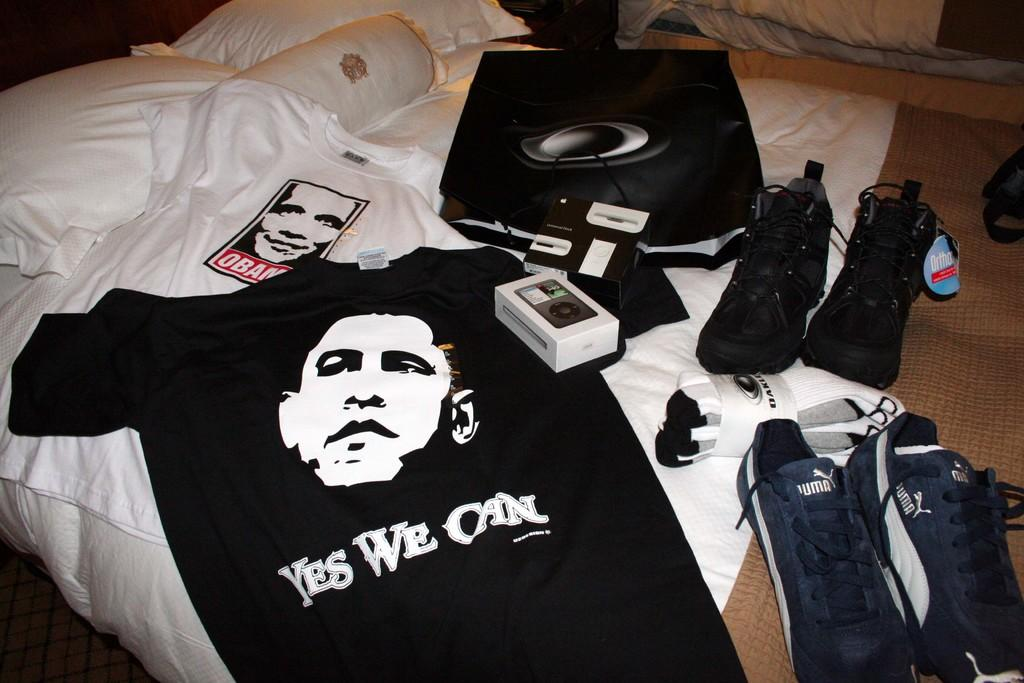What type of furniture is present in the image? There is a bed in the image. What is on the bed? The bed has pillows, t-shirts, shoes, socks, and a box. Are there any other items on the bed? Yes, there are other items on the bed. What type of event is taking place in the image? There is no event taking place in the image; it is a still image of a bed with various items on it. Can you describe the teeth of the person in the image? There is no person present in the image, so it is not possible to describe their teeth. 